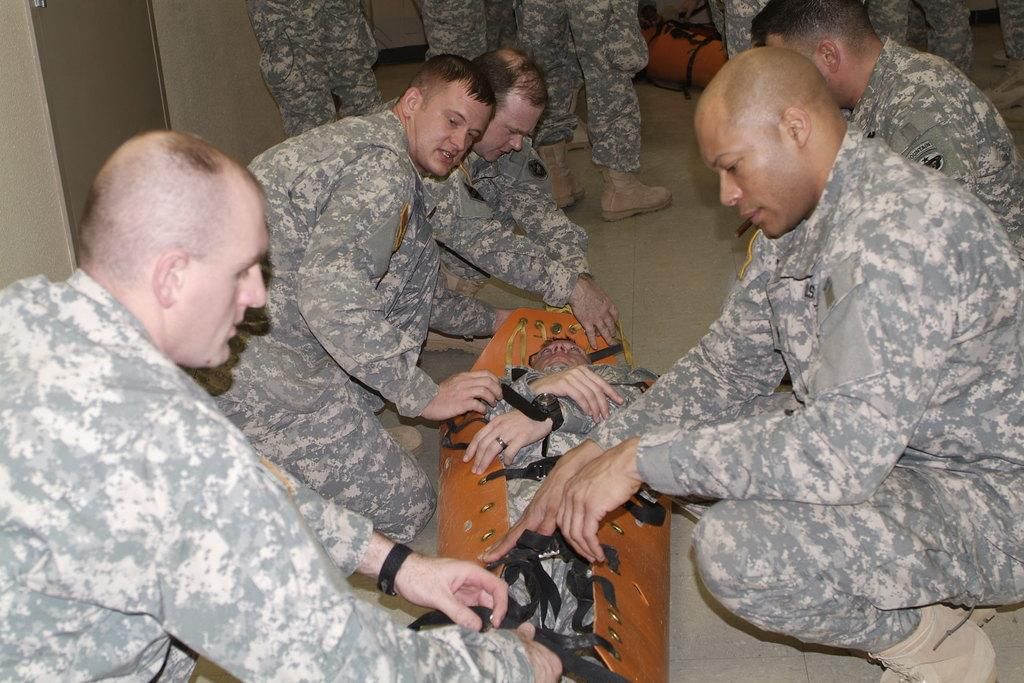What type of people are in the image? There are military soldiers in the image. What are the soldiers doing in the image? The soldiers are sitting on the ground and covering a dead body. What can be inferred about the dead person in the image? The dead person is also a military soldier. What material is used to cover the body? The cloth used to cover the body is made of brown leather. What type of tooth is visible in the image? There is no tooth visible in the image. Can you describe the position of the banana in the image? There is no banana present in the image. 